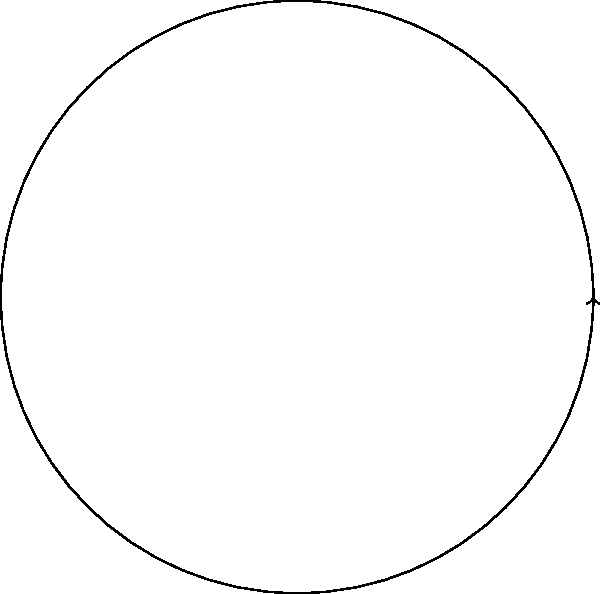Given a celestial object with equatorial coordinates $(\alpha, \delta) = (4^h 30^m, +30^\circ)$, determine its polar coordinates $(r, \theta)$ assuming the object is on the celestial sphere with radius $R = 1$. Express $\theta$ in degrees. To transform equatorial coordinates $(\alpha, \delta)$ to polar coordinates $(r, \theta)$, we follow these steps:

1) First, convert the right ascension $\alpha$ from hours to degrees:
   $\alpha = 4^h 30^m = 4.5^h = 4.5 \times 15^\circ = 67.5^\circ$

2) The declination $\delta$ is already in degrees: $\delta = 30^\circ$

3) For objects on the celestial sphere, the radial distance $r$ is constant and equal to the sphere's radius. Here, $r = R = 1$.

4) To find $\theta$, we use the relation: $\theta = 90^\circ - \delta = 90^\circ - 30^\circ = 60^\circ$

5) Note that $\alpha$ doesn't directly affect $\theta$ in this transformation, but it would be used to determine the object's position in the $xy$-plane if needed.

Therefore, the polar coordinates are $(r, \theta) = (1, 60^\circ)$.
Answer: $(1, 60^\circ)$ 